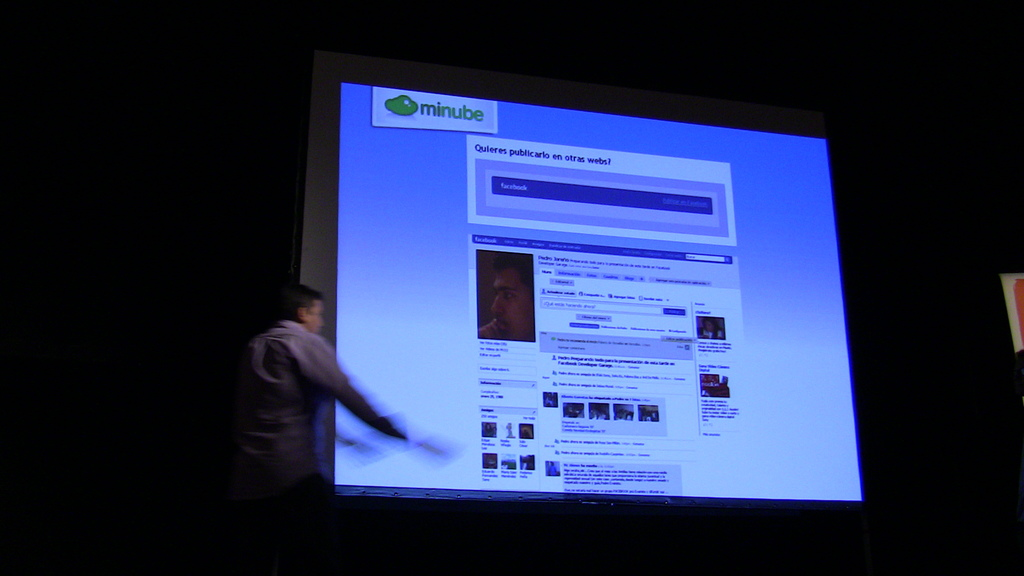Can you describe the atmosphere or setting of the presentation? The setting is quite professional and focused, with the room's lighting dimmed to enhance visibility of the brightly lit screen, while the attendees seem attentively watching the presenter. 